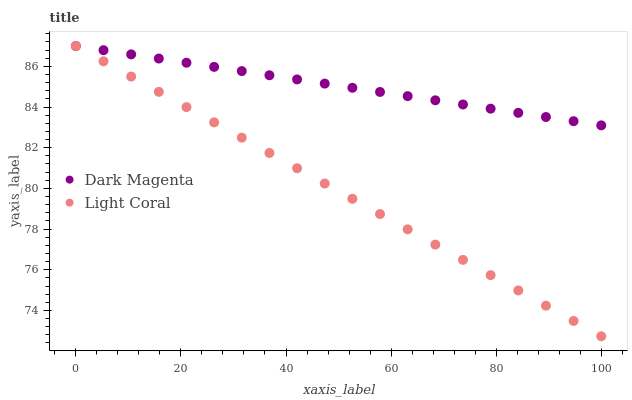Does Light Coral have the minimum area under the curve?
Answer yes or no. Yes. Does Dark Magenta have the maximum area under the curve?
Answer yes or no. Yes. Does Dark Magenta have the minimum area under the curve?
Answer yes or no. No. Is Light Coral the smoothest?
Answer yes or no. Yes. Is Dark Magenta the roughest?
Answer yes or no. Yes. Is Dark Magenta the smoothest?
Answer yes or no. No. Does Light Coral have the lowest value?
Answer yes or no. Yes. Does Dark Magenta have the lowest value?
Answer yes or no. No. Does Dark Magenta have the highest value?
Answer yes or no. Yes. Does Dark Magenta intersect Light Coral?
Answer yes or no. Yes. Is Dark Magenta less than Light Coral?
Answer yes or no. No. Is Dark Magenta greater than Light Coral?
Answer yes or no. No. 